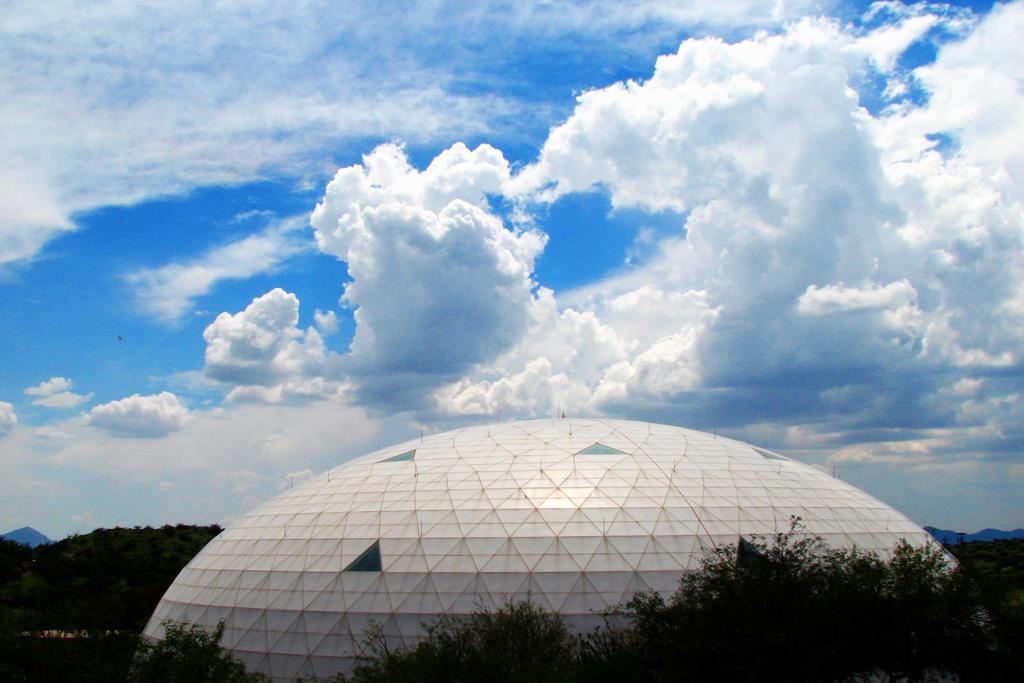Could you give a brief overview of what you see in this image? In this image I can see number of trees and a building in the front. In the background I can see clouds and the sky. 